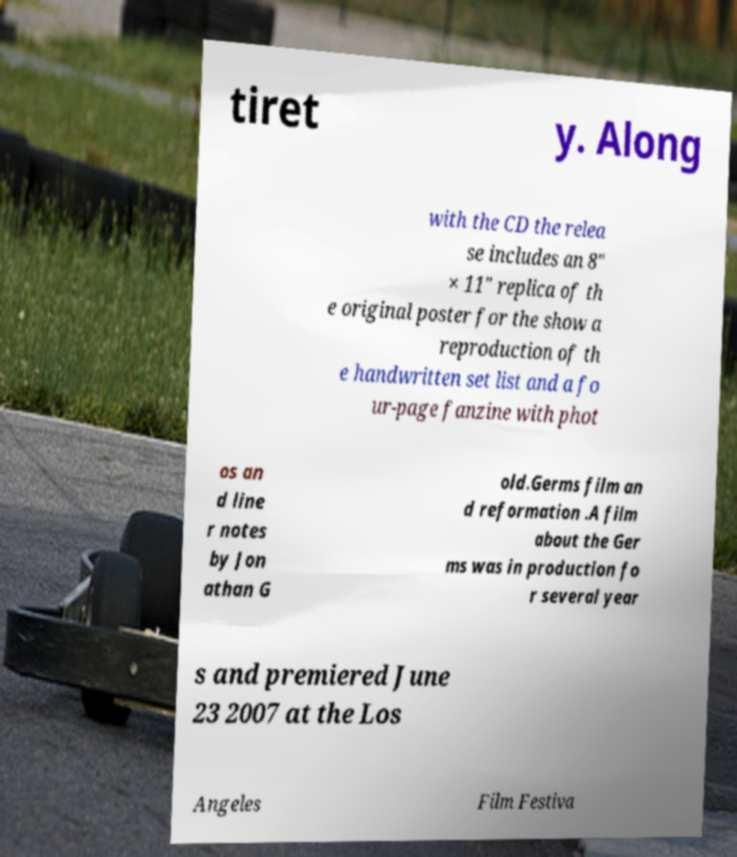Please read and relay the text visible in this image. What does it say? tiret y. Along with the CD the relea se includes an 8" × 11" replica of th e original poster for the show a reproduction of th e handwritten set list and a fo ur-page fanzine with phot os an d line r notes by Jon athan G old.Germs film an d reformation .A film about the Ger ms was in production fo r several year s and premiered June 23 2007 at the Los Angeles Film Festiva 